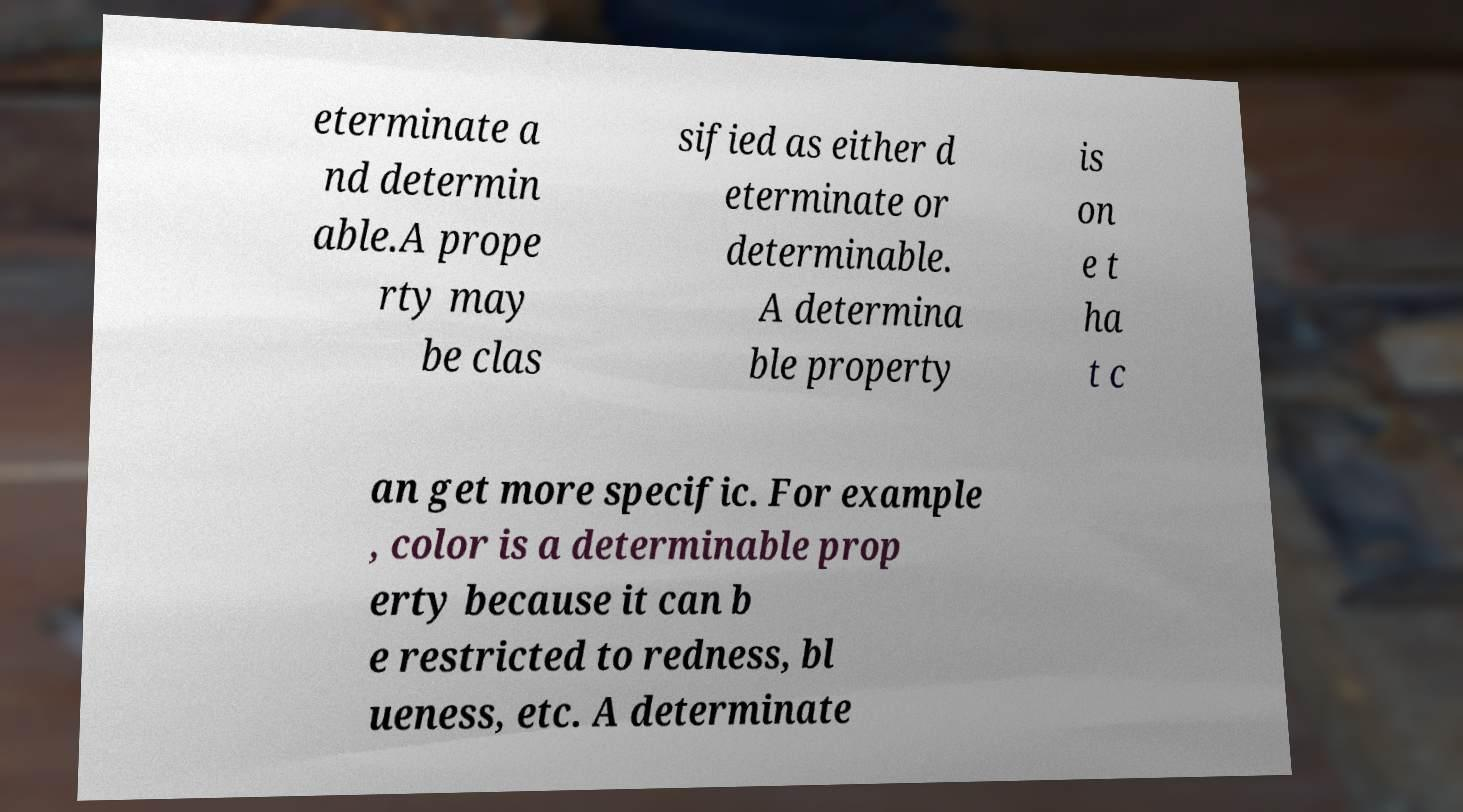Could you extract and type out the text from this image? eterminate a nd determin able.A prope rty may be clas sified as either d eterminate or determinable. A determina ble property is on e t ha t c an get more specific. For example , color is a determinable prop erty because it can b e restricted to redness, bl ueness, etc. A determinate 